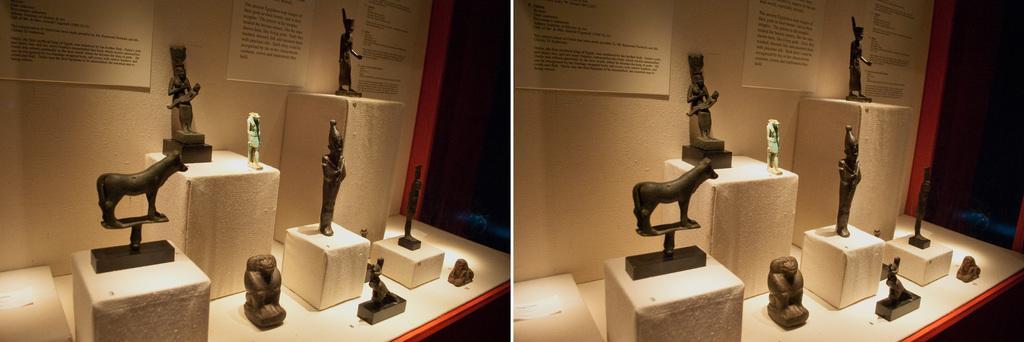Please provide a concise description of this image. This image is a collage. In this image we can see a table and there are sculptures placed on the table. There are boards placed on the walls. 